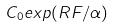Convert formula to latex. <formula><loc_0><loc_0><loc_500><loc_500>C _ { 0 } e x p ( R F / \alpha )</formula> 